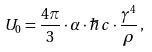Convert formula to latex. <formula><loc_0><loc_0><loc_500><loc_500>U _ { 0 } = \frac { 4 \pi } { 3 } \cdot \alpha \cdot \hbar { c } \cdot \frac { \gamma ^ { 4 } } { \rho } \, ,</formula> 